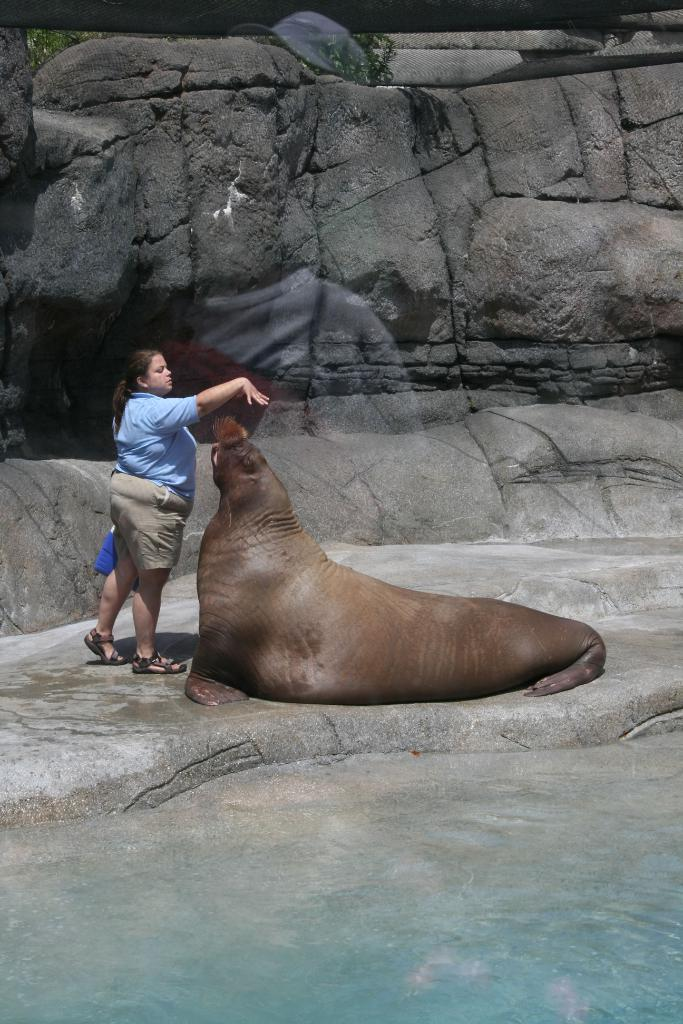What is present at the bottom of the image? There is water at the bottom of the image. What animals or people can be seen in the image? A woman is standing beside a seal in the image. What type of natural features are visible in the background? There are rocks and a plant visible in the background of the image. How many cakes are being served by the woman in the image? There are no cakes present in the image; the woman is standing beside a seal. What type of care is the woman providing to the seal in the image? The image does not show any indication of care being provided; the woman is simply standing beside the seal. 